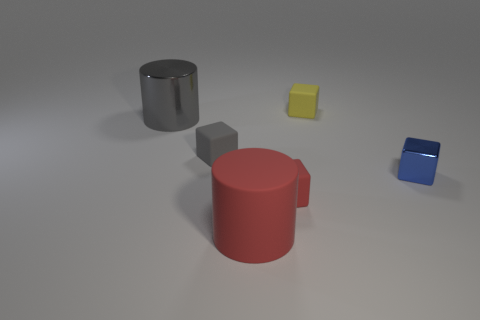Subtract all yellow blocks. Subtract all green balls. How many blocks are left? 3 Add 3 large brown balls. How many objects exist? 9 Subtract all cylinders. How many objects are left? 4 Subtract 0 cyan cubes. How many objects are left? 6 Subtract all rubber cubes. Subtract all tiny metal blocks. How many objects are left? 2 Add 1 red blocks. How many red blocks are left? 2 Add 6 small blue objects. How many small blue objects exist? 7 